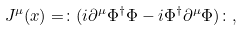Convert formula to latex. <formula><loc_0><loc_0><loc_500><loc_500>J ^ { \mu } ( x ) = \colon ( i \partial ^ { \mu } \Phi ^ { \dagger } \Phi - i \Phi ^ { \dagger } \partial ^ { \mu } \Phi ) \colon ,</formula> 